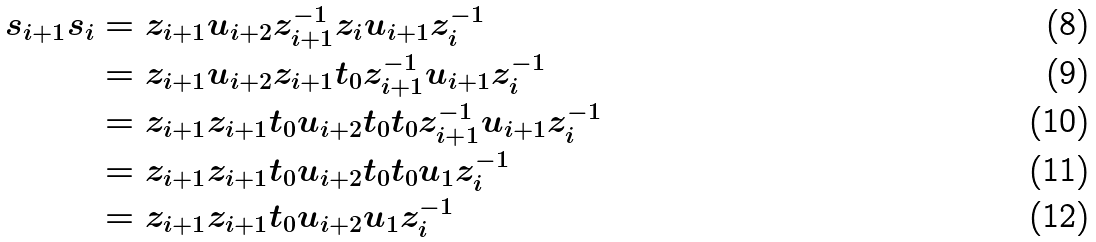Convert formula to latex. <formula><loc_0><loc_0><loc_500><loc_500>s _ { i + 1 } s _ { i } & = z _ { i + 1 } u _ { i + 2 } z _ { i + 1 } ^ { - 1 } z _ { i } u _ { i + 1 } z _ { i } ^ { - 1 } \\ & = z _ { i + 1 } u _ { i + 2 } z _ { i + 1 } t _ { 0 } z _ { i + 1 } ^ { - 1 } u _ { i + 1 } z _ { i } ^ { - 1 } \\ & = z _ { i + 1 } z _ { i + 1 } t _ { 0 } u _ { i + 2 } t _ { 0 } t _ { 0 } z _ { i + 1 } ^ { - 1 } u _ { i + 1 } z _ { i } ^ { - 1 } \\ & = z _ { i + 1 } z _ { i + 1 } t _ { 0 } u _ { i + 2 } t _ { 0 } t _ { 0 } u _ { 1 } z _ { i } ^ { - 1 } \\ & = z _ { i + 1 } z _ { i + 1 } t _ { 0 } u _ { i + 2 } u _ { 1 } z _ { i } ^ { - 1 }</formula> 